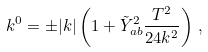Convert formula to latex. <formula><loc_0><loc_0><loc_500><loc_500>k ^ { 0 } = \pm | k | \left ( 1 + \tilde { Y } _ { a b } ^ { 2 } \frac { T ^ { 2 } } { 2 4 k ^ { 2 } } \right ) \, ,</formula> 